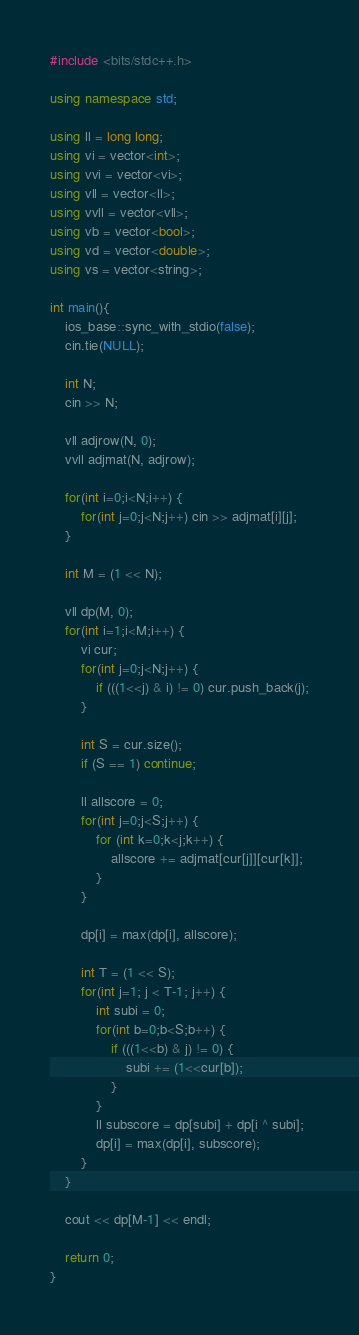<code> <loc_0><loc_0><loc_500><loc_500><_C++_>#include <bits/stdc++.h>

using namespace std;

using ll = long long;
using vi = vector<int>;
using vvi = vector<vi>;
using vll = vector<ll>;
using vvll = vector<vll>;
using vb = vector<bool>;
using vd = vector<double>;
using vs = vector<string>;

int main(){
    ios_base::sync_with_stdio(false);
    cin.tie(NULL);

    int N;
    cin >> N;

    vll adjrow(N, 0);
    vvll adjmat(N, adjrow);

    for(int i=0;i<N;i++) {
        for(int j=0;j<N;j++) cin >> adjmat[i][j];
    }

    int M = (1 << N);

    vll dp(M, 0);
    for(int i=1;i<M;i++) {
        vi cur;
        for(int j=0;j<N;j++) {
            if (((1<<j) & i) != 0) cur.push_back(j);
        }

        int S = cur.size();
        if (S == 1) continue;

        ll allscore = 0;
        for(int j=0;j<S;j++) {
            for (int k=0;k<j;k++) {
                allscore += adjmat[cur[j]][cur[k]];
            }
        }

        dp[i] = max(dp[i], allscore);

        int T = (1 << S);
        for(int j=1; j < T-1; j++) {
            int subi = 0;
            for(int b=0;b<S;b++) {
                if (((1<<b) & j) != 0) {
                    subi += (1<<cur[b]);
                }
            }
            ll subscore = dp[subi] + dp[i ^ subi];
            dp[i] = max(dp[i], subscore);
        }
    }

    cout << dp[M-1] << endl;

    return 0;
}</code> 